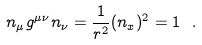<formula> <loc_0><loc_0><loc_500><loc_500>n _ { \mu } g ^ { \mu \nu } n _ { \nu } = \frac { 1 } { r ^ { 2 } } ( n _ { x } ) ^ { 2 } = 1 \ .</formula> 